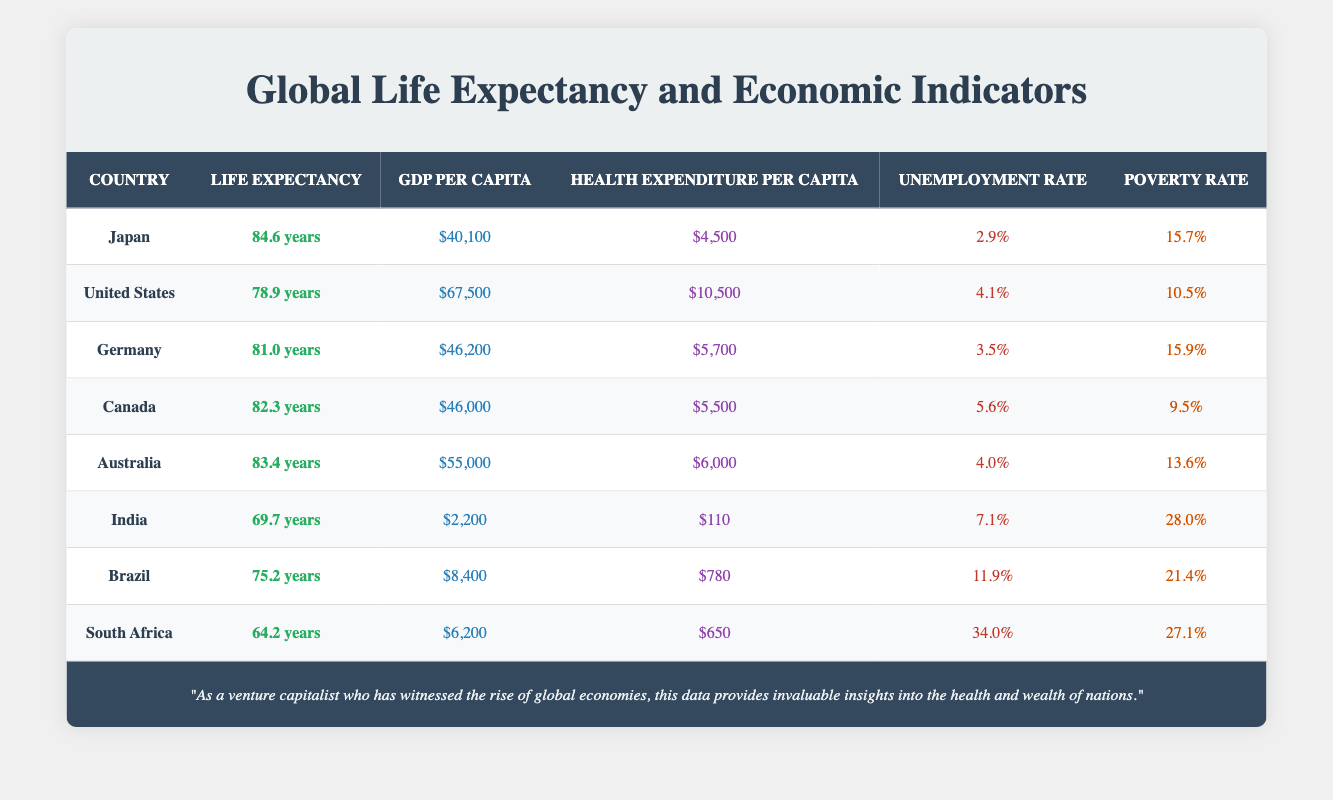What is the life expectancy of South Africa? The table lists South Africa's life expectancy as 64.2 years in the corresponding row.
Answer: 64.2 years Which country has the highest GDP per capita? In the table, the United States has the highest GDP per capita at $67,500 compared to other countries listed.
Answer: United States What is the average life expectancy of the countries in the table? To calculate the average, add the life expectancies: 84.6 + 78.9 + 81.0 + 82.3 + 83.4 + 69.7 + 75.2 + 64.2 =  539.3. Divide by the number of countries (8): 539.3 / 8 = 67.4125.
Answer: 75.8 years Is Japan's unemployment rate lower than that of Germany? Japan's unemployment rate is 2.9% while Germany's is 3.5%. Since 2.9 is less than 3.5, Japan does indeed have a lower unemployment rate.
Answer: Yes How much higher is the GDP per capita of Australia compared to India? Australia has a GDP per capita of $55,000 and India has $2,200. Subtract India's GDP from Australia's: $55,000 - $2,200 = $52,800.
Answer: $52,800 Which country has the lowest life expectancy? The table shows that South Africa has the lowest life expectancy at 64.2 years, which is the least among all countries listed.
Answer: South Africa Is the poverty rate in Canada lower than that of Brazil? Canada has a poverty rate of 9.5% while Brazil has a poverty rate of 21.4%. Since 9.5 is less than 21.4, Canada does have a lower poverty rate than Brazil.
Answer: Yes What is the difference in health expenditure per capita between Germany and Australia? Germany has a health expenditure of $5,700 and Australia has $6,000. The difference is $6,000 - $5,700 = $300.
Answer: $300 Which country has both a higher life expectancy and a lower unemployment rate compared to the United States? Canada qualifies with a life expectancy of 82.3 years and an unemployment rate of 5.6%, which are both better than the United States' life expectancy of 78.9 years and unemployment rate of 4.1%.
Answer: Canada 